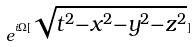<formula> <loc_0><loc_0><loc_500><loc_500>e ^ { i \Omega [ \sqrt { t ^ { 2 } - x ^ { 2 } - y ^ { 2 } - z ^ { 2 } } ] }</formula> 